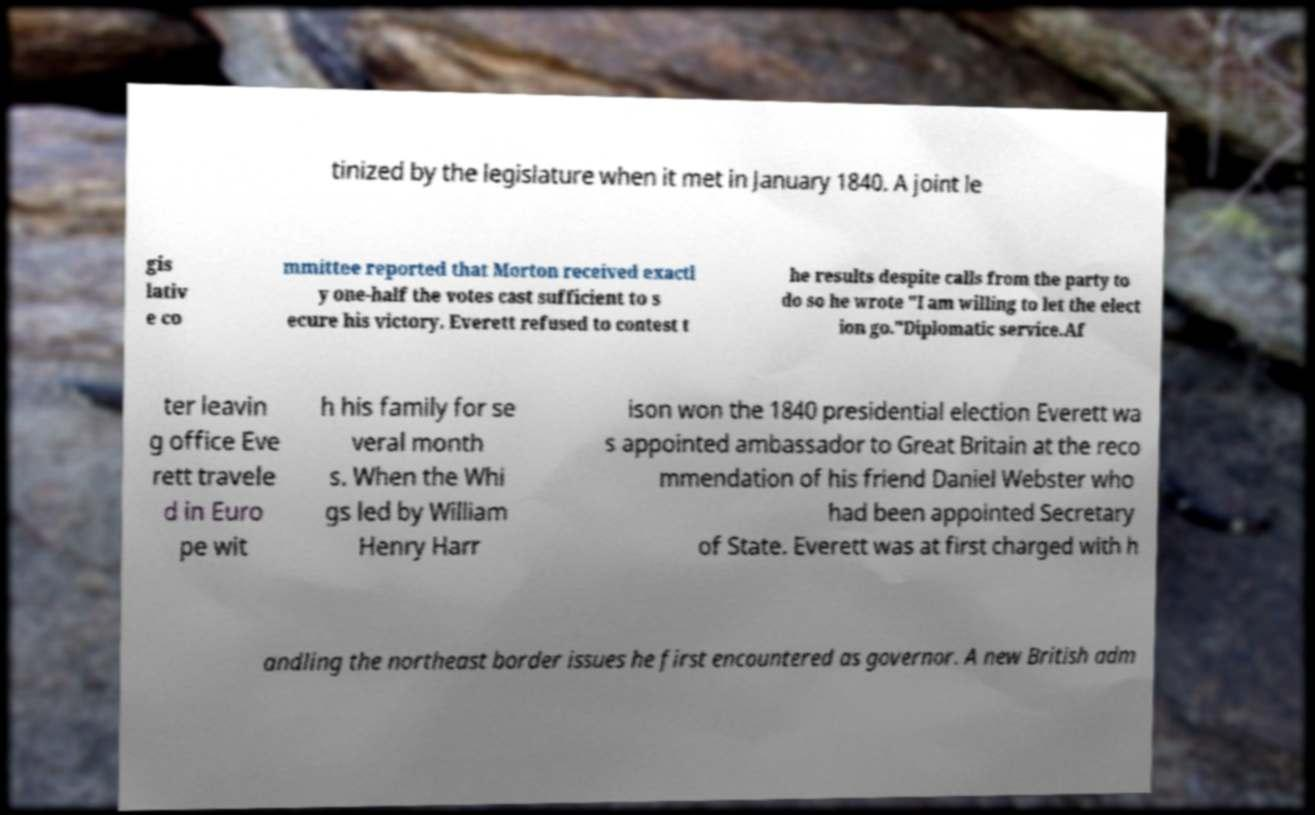I need the written content from this picture converted into text. Can you do that? tinized by the legislature when it met in January 1840. A joint le gis lativ e co mmittee reported that Morton received exactl y one-half the votes cast sufficient to s ecure his victory. Everett refused to contest t he results despite calls from the party to do so he wrote "I am willing to let the elect ion go."Diplomatic service.Af ter leavin g office Eve rett travele d in Euro pe wit h his family for se veral month s. When the Whi gs led by William Henry Harr ison won the 1840 presidential election Everett wa s appointed ambassador to Great Britain at the reco mmendation of his friend Daniel Webster who had been appointed Secretary of State. Everett was at first charged with h andling the northeast border issues he first encountered as governor. A new British adm 